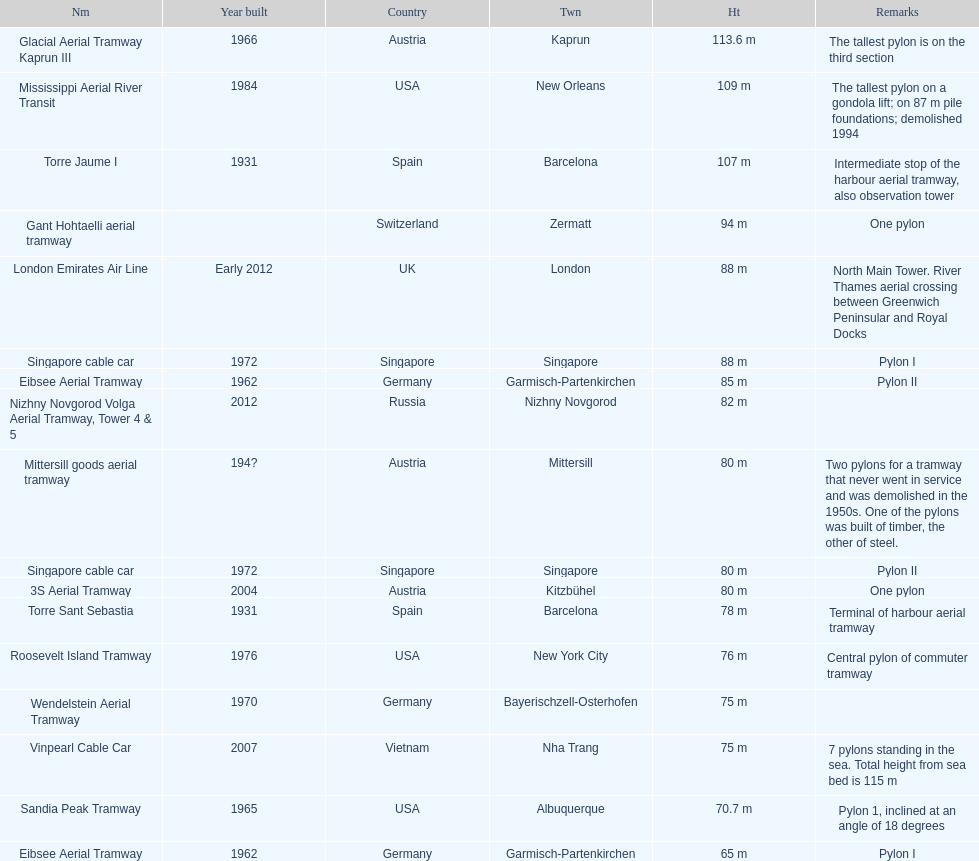What is the pylon with the least height listed here? Eibsee Aerial Tramway. 